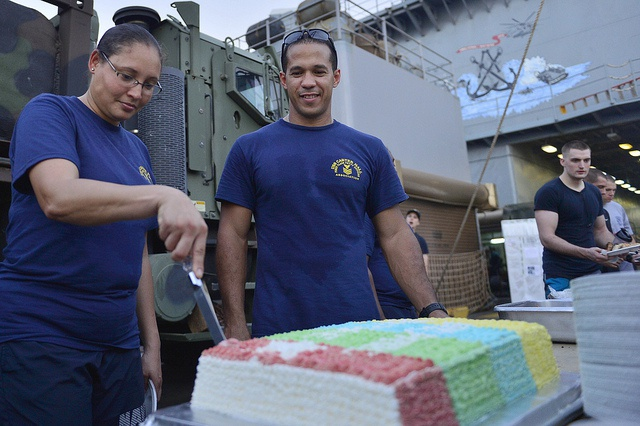Describe the objects in this image and their specific colors. I can see people in navy, black, darkgray, and gray tones, people in navy, gray, and black tones, cake in navy, lightblue, darkgray, and teal tones, truck in navy, gray, black, and darkblue tones, and people in navy, black, darkgray, and gray tones in this image. 